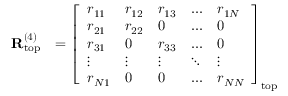Convert formula to latex. <formula><loc_0><loc_0><loc_500><loc_500>\begin{array} { r l } { R _ { t o p } ^ { ( 4 ) } } & { = \left [ \begin{array} { l l l l l } { r _ { 1 1 } } & { r _ { 1 2 } } & { r _ { 1 3 } } & { \dots } & { r _ { 1 N } } \\ { r _ { 2 1 } } & { r _ { 2 2 } } & { 0 } & { \dots } & { 0 } \\ { r _ { 3 1 } } & { 0 } & { r _ { 3 3 } } & { \dots } & { 0 } \\ { \vdots } & { \vdots } & { \vdots } & { \ddots } & { \vdots } \\ { r _ { N 1 } } & { 0 } & { 0 } & { \dots } & { r _ { N N } } \end{array} \right ] _ { t o p } } \end{array}</formula> 